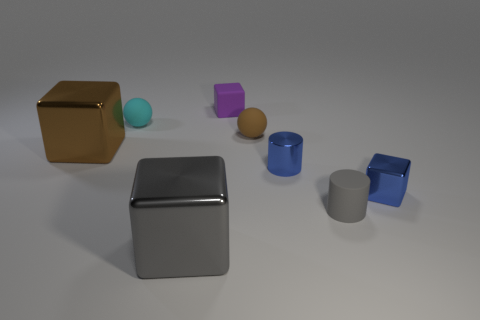Subtract all yellow blocks. Subtract all green cylinders. How many blocks are left? 4 Add 1 large rubber balls. How many objects exist? 9 Subtract all spheres. How many objects are left? 6 Add 8 small metal cylinders. How many small metal cylinders exist? 9 Subtract 0 yellow balls. How many objects are left? 8 Subtract all small gray rubber objects. Subtract all cylinders. How many objects are left? 5 Add 8 small blue metal blocks. How many small blue metal blocks are left? 9 